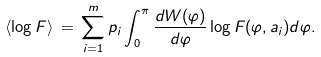<formula> <loc_0><loc_0><loc_500><loc_500>\langle \log F \rangle \, = \, \sum _ { i = 1 } ^ { m } p _ { i } \int _ { 0 } ^ { \pi } \frac { d W ( \varphi ) } { d \varphi } \log F ( \varphi , a _ { i } ) d \varphi .</formula> 